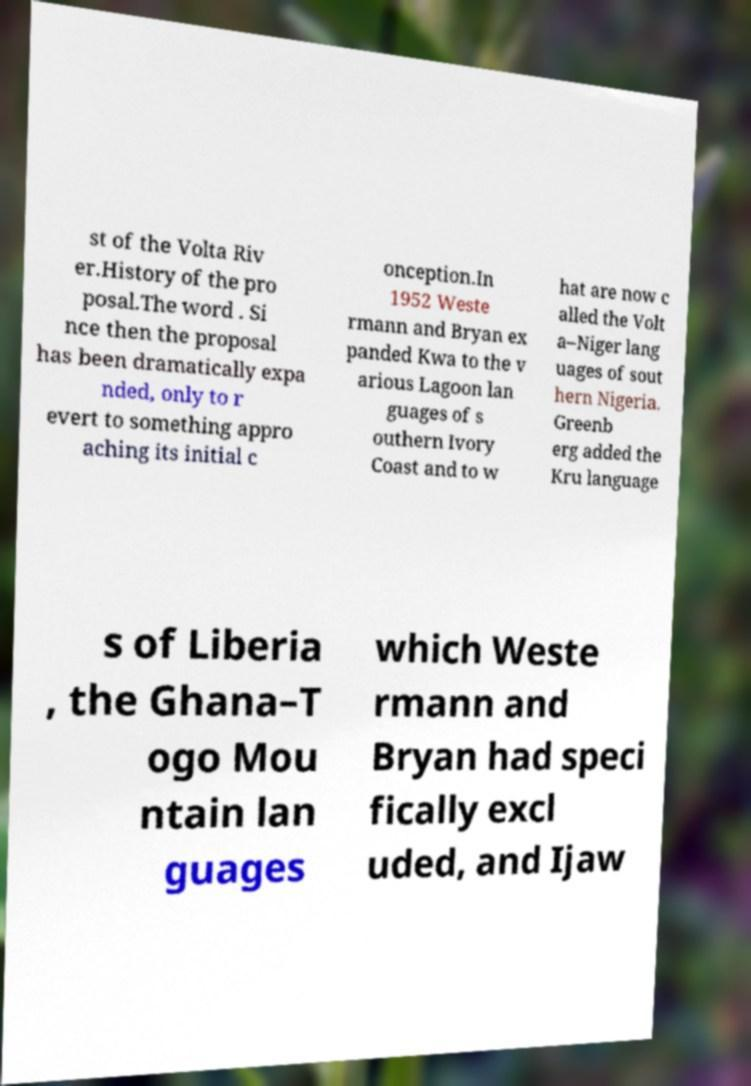I need the written content from this picture converted into text. Can you do that? st of the Volta Riv er.History of the pro posal.The word . Si nce then the proposal has been dramatically expa nded, only to r evert to something appro aching its initial c onception.In 1952 Weste rmann and Bryan ex panded Kwa to the v arious Lagoon lan guages of s outhern Ivory Coast and to w hat are now c alled the Volt a–Niger lang uages of sout hern Nigeria. Greenb erg added the Kru language s of Liberia , the Ghana–T ogo Mou ntain lan guages which Weste rmann and Bryan had speci fically excl uded, and Ijaw 